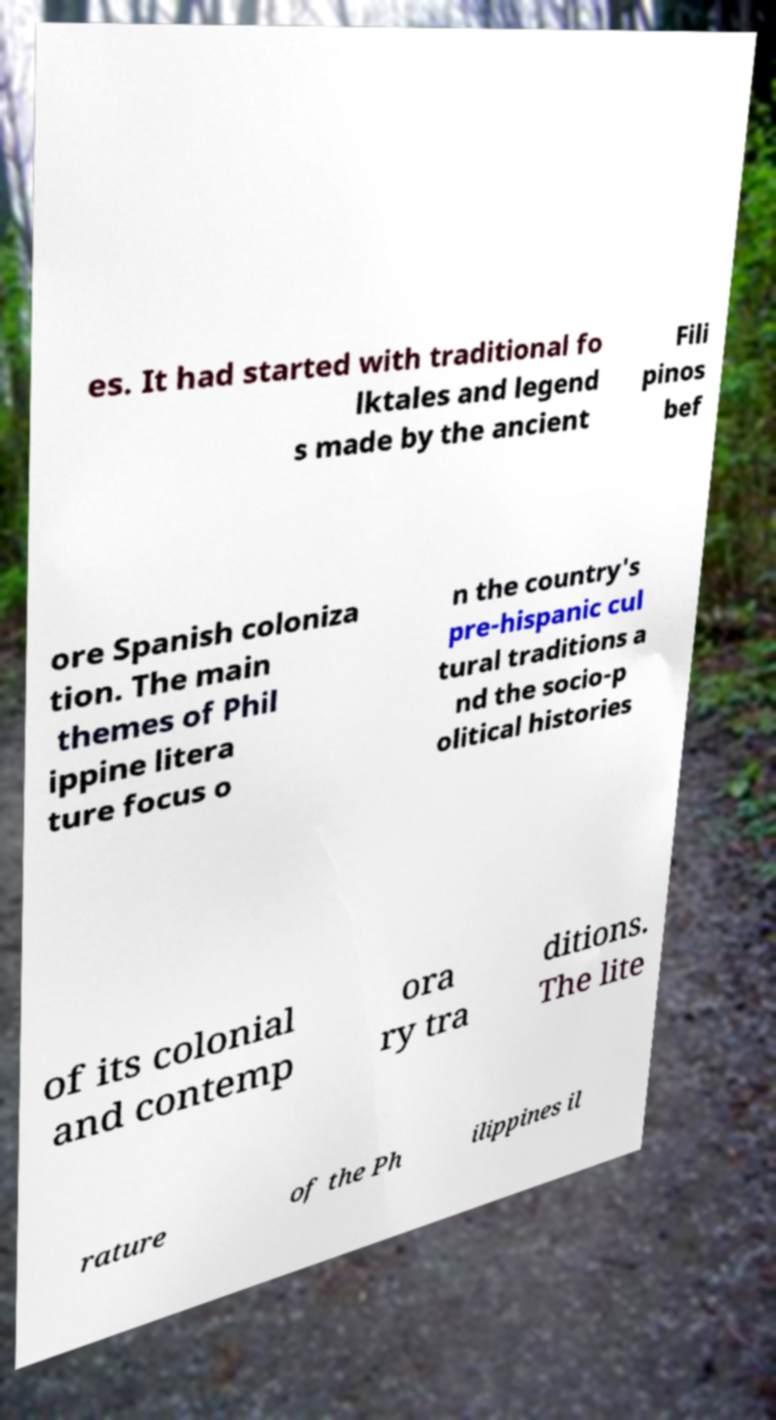What messages or text are displayed in this image? I need them in a readable, typed format. es. It had started with traditional fo lktales and legend s made by the ancient Fili pinos bef ore Spanish coloniza tion. The main themes of Phil ippine litera ture focus o n the country's pre-hispanic cul tural traditions a nd the socio-p olitical histories of its colonial and contemp ora ry tra ditions. The lite rature of the Ph ilippines il 